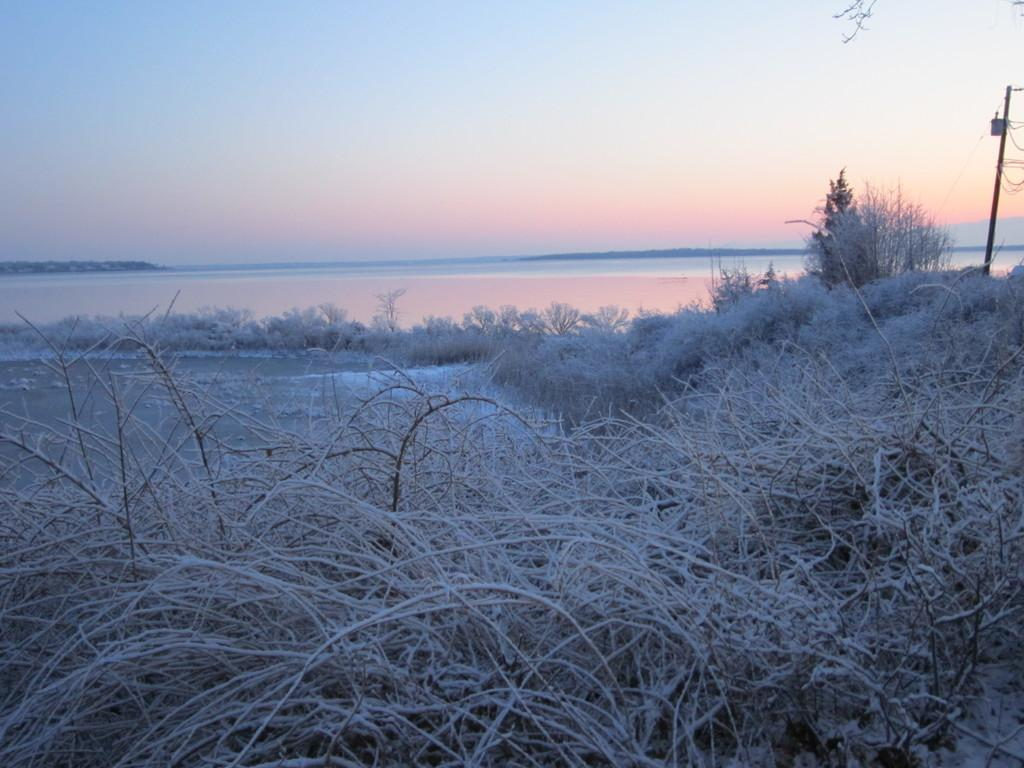What type of weather is depicted in the image? There is snow in the image, indicating cold weather. What other elements can be seen in the image besides the snow? There are plants, an electric pole on the right side, water visible, and clouds in the sky. Can you describe the vegetation in the image? The plants in the image are likely to be cold-weather plants, given the snowy environment. What is the condition of the sky in the image? Clouds are present in the sky, which may indicate an overcast or snowy day. What type of music is being played by the governor in the image? There is no governor or music present in the image; it features snow, plants, an electric pole, water, and clouds. 